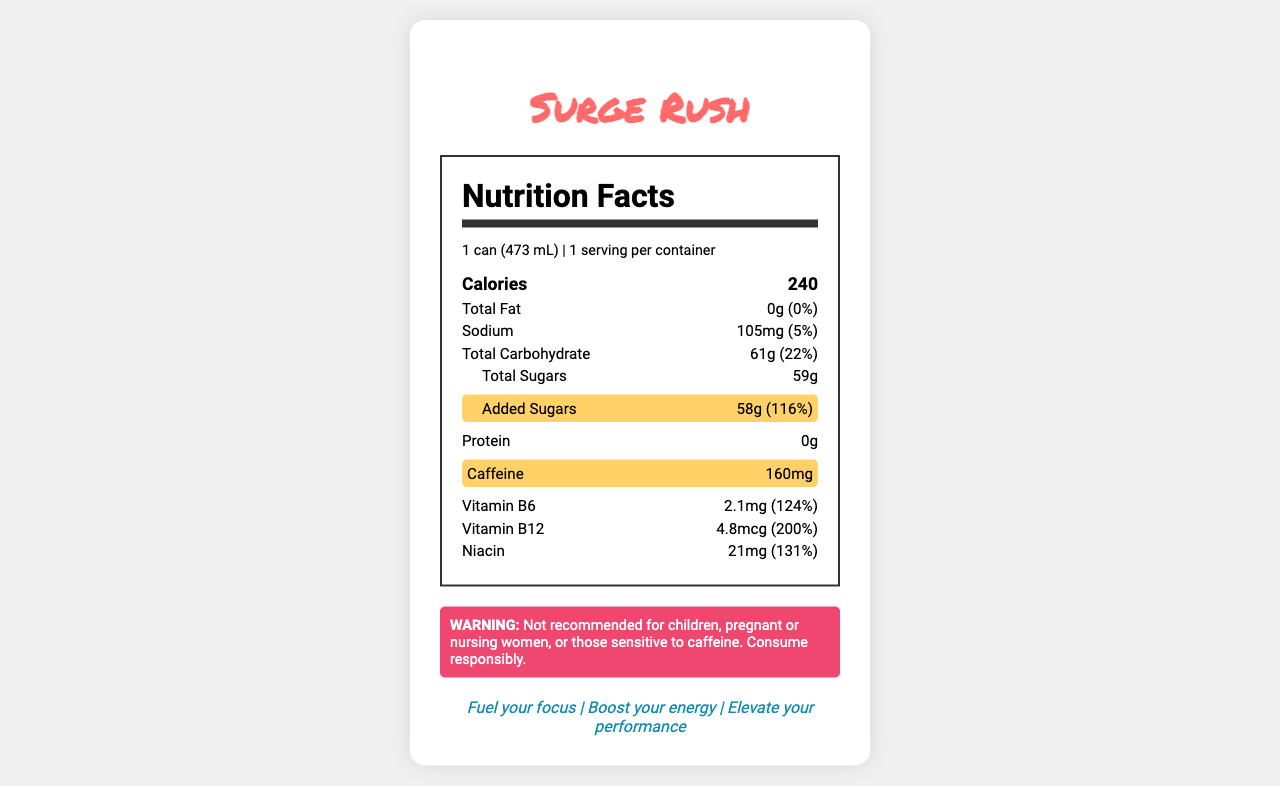what is the serving size of Surge Rush? The serving size is explicitly stated in the nutrition facts label as "1 can (473 mL)".
Answer: 1 can (473 mL) how much added sugars does Surge Rush contain? The amount of added sugars is highlighted in the nutrition label as 58g, which constitutes 116% of the daily value.
Answer: 58g how much caffeine is in one can of Surge Rush? The nutrition label lists 160mg of caffeine as the amount contained within one can.
Answer: 160mg how many calories are there in one can of Surge Rush? The label shows that each can contains 240 calories.
Answer: 240 what is the percent daily value of sodium in one serving? The sodium content is listed as 105mg, which is 5% of the daily value.
Answer: 5% which vitamin is present in the largest amount based on percent daily value? A. Vitamin B6 B. Vitamin B12 C. Niacin Vitamin B12 comprises 200% of the daily value, which is higher compared to the other vitamins listed.
Answer: B. Vitamin B12 how does the caffeine content of Surge Rush compare to a regular cola? A. Same as a regular cola B. Twice the caffeine of a regular cola C. Half the caffeine of a regular cola D. Ten times the caffeine of a regular cola The label explicitly mentions that Surge Rush has twice the caffeine of a regular cola.
Answer: B. Twice the caffeine of a regular cola Does Surge Rush contain any protein? The label indicates 0g of protein content.
Answer: No Is Surge Rush recommended for children? The warning statement clearly indicates that it is not recommended for children.
Answer: No summarize the key health-related concerns described in the Surge Rush nutrition facts label. The document points out that Surge Rush is high in caffeine and added sugars, which are highlighted as significant health concerns. The product carries warnings for certain groups and targets young consumers with specific marketing claims.
Answer: Surge Rush contains high levels of caffeine (160mg) and added sugars (58g), which contribute to significant portions of daily values (116% for added sugars). It is not recommended for children, pregnant or nursing women, or those sensitive to caffeine. The product is marketed to boost focus and energy, mainly targeting teens and young adults. how many servings are there in one container of Surge Rush? The nutrition label states that there is 1 serving per container.
Answer: 1 serving What is the color of Surge Rush? The visual information in the document does not provide any details about the color of the beverage.
Answer: Cannot be determined 